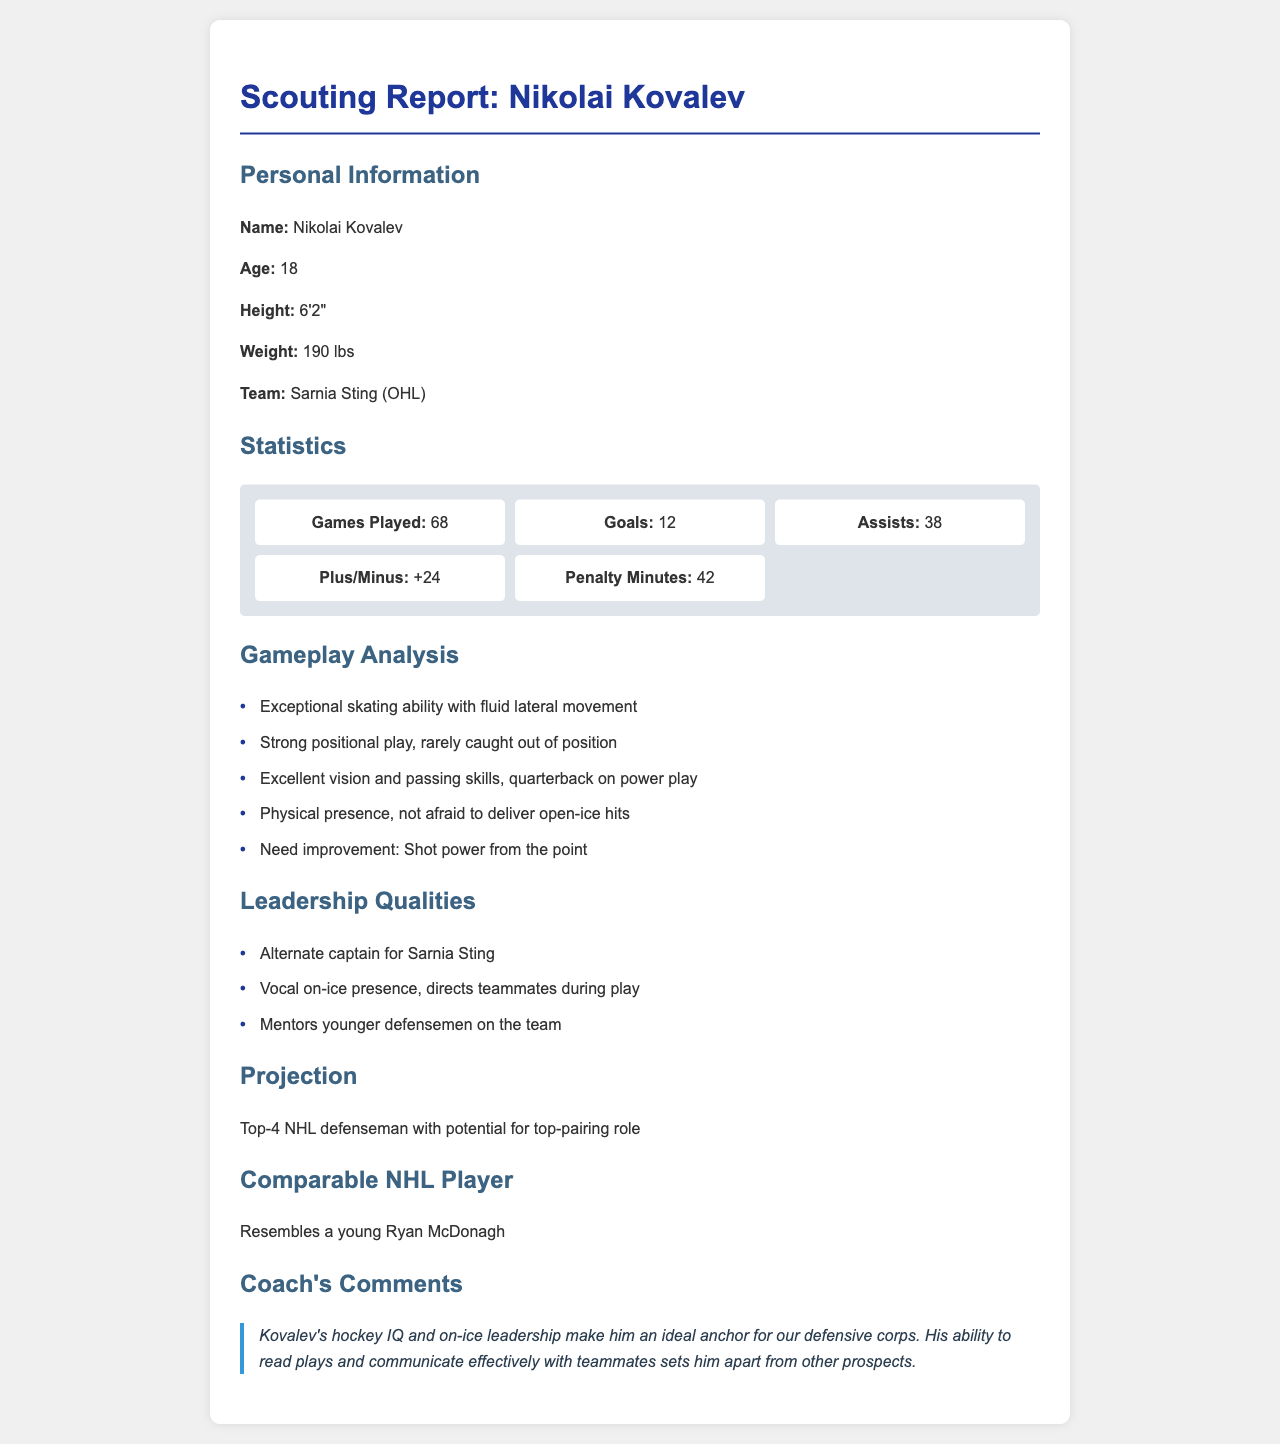What is Nikolai Kovalev's age? The document specifies that Nikolai Kovalev is 18 years old.
Answer: 18 How many goals did Kovalev score? The statistics section shows that Kovalev scored 12 goals during the season.
Answer: 12 What is Kovalev's plus/minus rating? The document indicates a plus/minus rating of +24.
Answer: +24 What team does Kovalev play for? The document mentions that he plays for the Sarnia Sting.
Answer: Sarnia Sting What leadership role does Kovalev hold on his team? The report states that he is an alternate captain for the Sarnia Sting.
Answer: Alternate captain What area does Kovalev need to improve in? The gameplay analysis mentions he needs improvement in shot power from the point.
Answer: Shot power from the point What comparable NHL player is mentioned? The document states that Kovalev resembles a young Ryan McDonagh.
Answer: Ryan McDonagh What is the projected role for Kovalev in the NHL? The projection section describes him as a top-4 NHL defenseman with potential for a top-pairing role.
Answer: Top-4 NHL defenseman What is a notable quality of Kovalev according to the coach? The coach's comments highlight Kovalev's hockey IQ as a notable quality.
Answer: Hockey IQ 